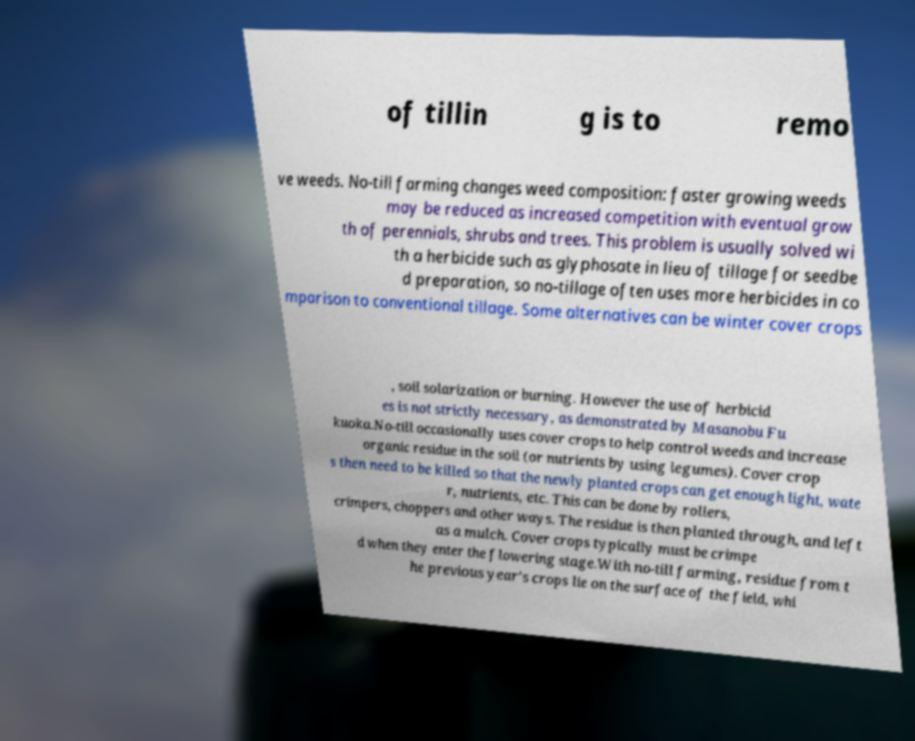Can you accurately transcribe the text from the provided image for me? of tillin g is to remo ve weeds. No-till farming changes weed composition: faster growing weeds may be reduced as increased competition with eventual grow th of perennials, shrubs and trees. This problem is usually solved wi th a herbicide such as glyphosate in lieu of tillage for seedbe d preparation, so no-tillage often uses more herbicides in co mparison to conventional tillage. Some alternatives can be winter cover crops , soil solarization or burning. However the use of herbicid es is not strictly necessary, as demonstrated by Masanobu Fu kuoka.No-till occasionally uses cover crops to help control weeds and increase organic residue in the soil (or nutrients by using legumes). Cover crop s then need to be killed so that the newly planted crops can get enough light, wate r, nutrients, etc. This can be done by rollers, crimpers, choppers and other ways. The residue is then planted through, and left as a mulch. Cover crops typically must be crimpe d when they enter the flowering stage.With no-till farming, residue from t he previous year's crops lie on the surface of the field, whi 